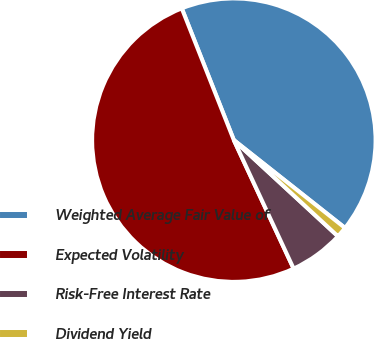<chart> <loc_0><loc_0><loc_500><loc_500><pie_chart><fcel>Weighted Average Fair Value of<fcel>Expected Volatility<fcel>Risk-Free Interest Rate<fcel>Dividend Yield<nl><fcel>41.63%<fcel>50.94%<fcel>6.2%<fcel>1.23%<nl></chart> 